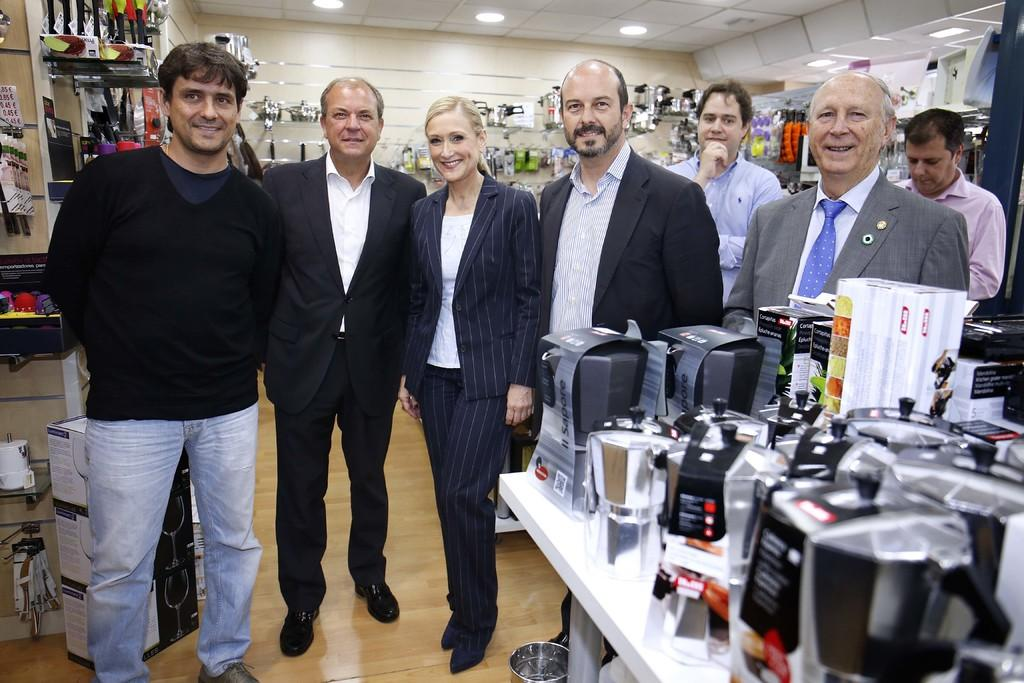What are the people in the image doing? The people in the image are standing and smiling. What can be seen in the background of the image? There are utensils visible in the background of the image. What is visible at the top of the image? There are lights visible at the top of the image. What is visible at the bottom of the image? There is a floor visible at the bottom of the image. Can you hear the people in the image coughing? There is no indication of coughing in the image, as it only shows people standing and smiling. 